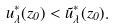Convert formula to latex. <formula><loc_0><loc_0><loc_500><loc_500>u ^ { * } _ { \lambda } ( z _ { 0 } ) < \tilde { u } ^ { * } _ { \lambda } ( z _ { 0 } ) .</formula> 